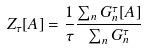Convert formula to latex. <formula><loc_0><loc_0><loc_500><loc_500>Z _ { \tau } [ A ] = \frac { 1 } { \tau } \frac { \sum _ { n } G ^ { \tau } _ { n } [ A ] } { \sum _ { n } G ^ { \tau } _ { n } }</formula> 